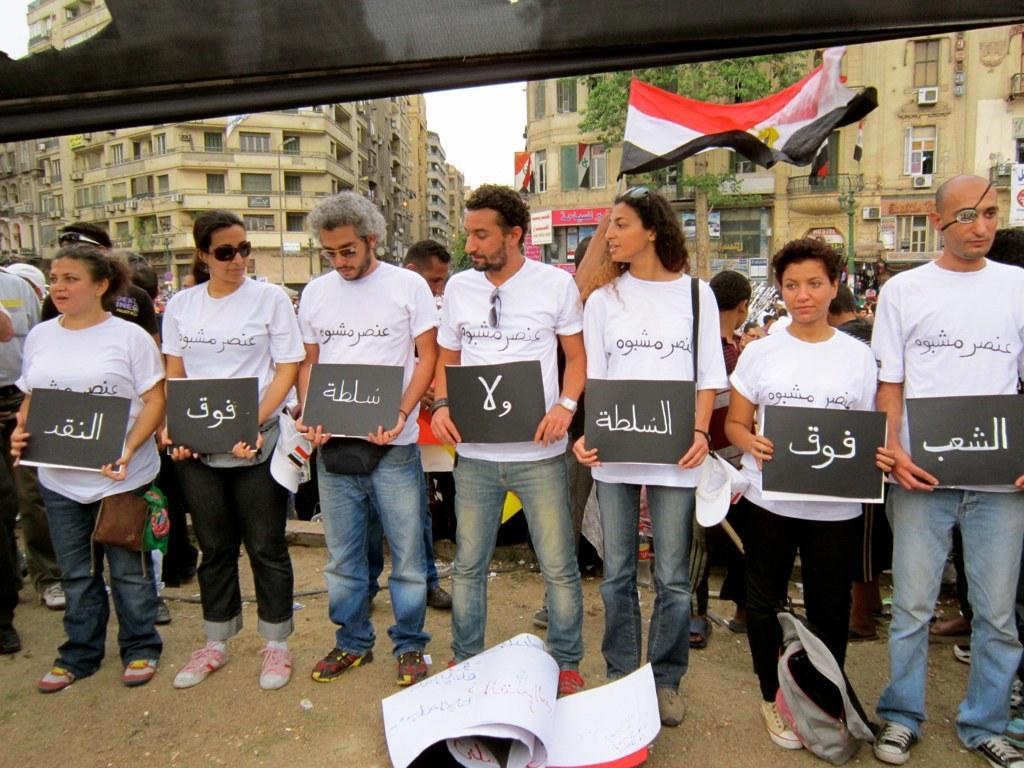Could you give a brief overview of what you see in this image? In this image, we can see a group of people wearing clothes and holding placards with their hands. There are some papers at the bottom of the image. There is a flag and buildings in the middle of the image. 